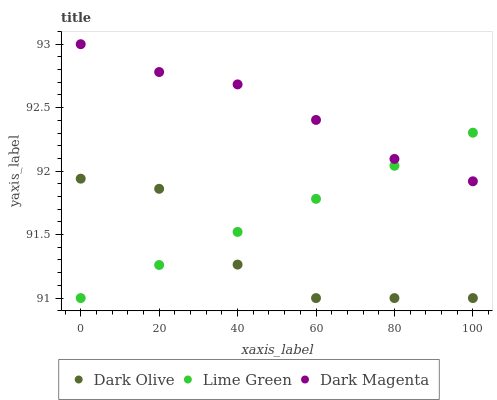Does Dark Olive have the minimum area under the curve?
Answer yes or no. Yes. Does Dark Magenta have the maximum area under the curve?
Answer yes or no. Yes. Does Lime Green have the minimum area under the curve?
Answer yes or no. No. Does Lime Green have the maximum area under the curve?
Answer yes or no. No. Is Lime Green the smoothest?
Answer yes or no. Yes. Is Dark Olive the roughest?
Answer yes or no. Yes. Is Dark Magenta the smoothest?
Answer yes or no. No. Is Dark Magenta the roughest?
Answer yes or no. No. Does Dark Olive have the lowest value?
Answer yes or no. Yes. Does Dark Magenta have the lowest value?
Answer yes or no. No. Does Dark Magenta have the highest value?
Answer yes or no. Yes. Does Lime Green have the highest value?
Answer yes or no. No. Is Dark Olive less than Dark Magenta?
Answer yes or no. Yes. Is Dark Magenta greater than Dark Olive?
Answer yes or no. Yes. Does Lime Green intersect Dark Olive?
Answer yes or no. Yes. Is Lime Green less than Dark Olive?
Answer yes or no. No. Is Lime Green greater than Dark Olive?
Answer yes or no. No. Does Dark Olive intersect Dark Magenta?
Answer yes or no. No. 